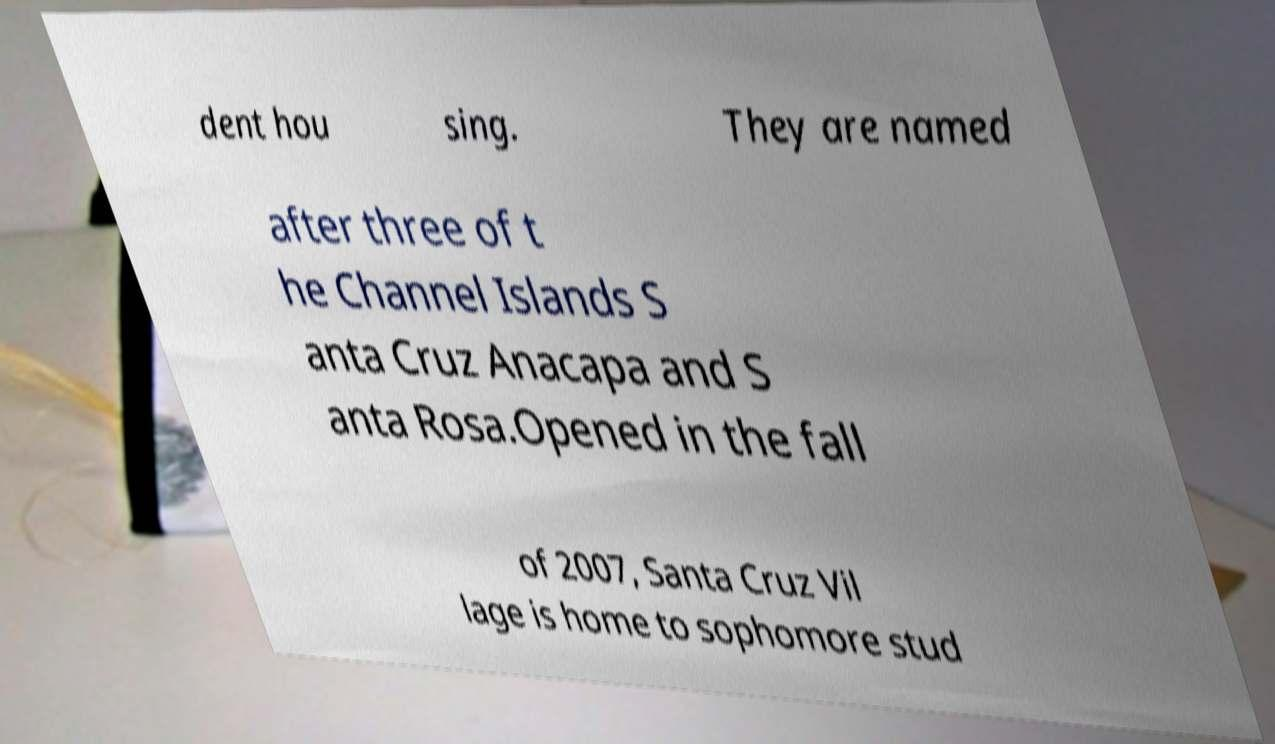Could you extract and type out the text from this image? dent hou sing. They are named after three of t he Channel Islands S anta Cruz Anacapa and S anta Rosa.Opened in the fall of 2007, Santa Cruz Vil lage is home to sophomore stud 